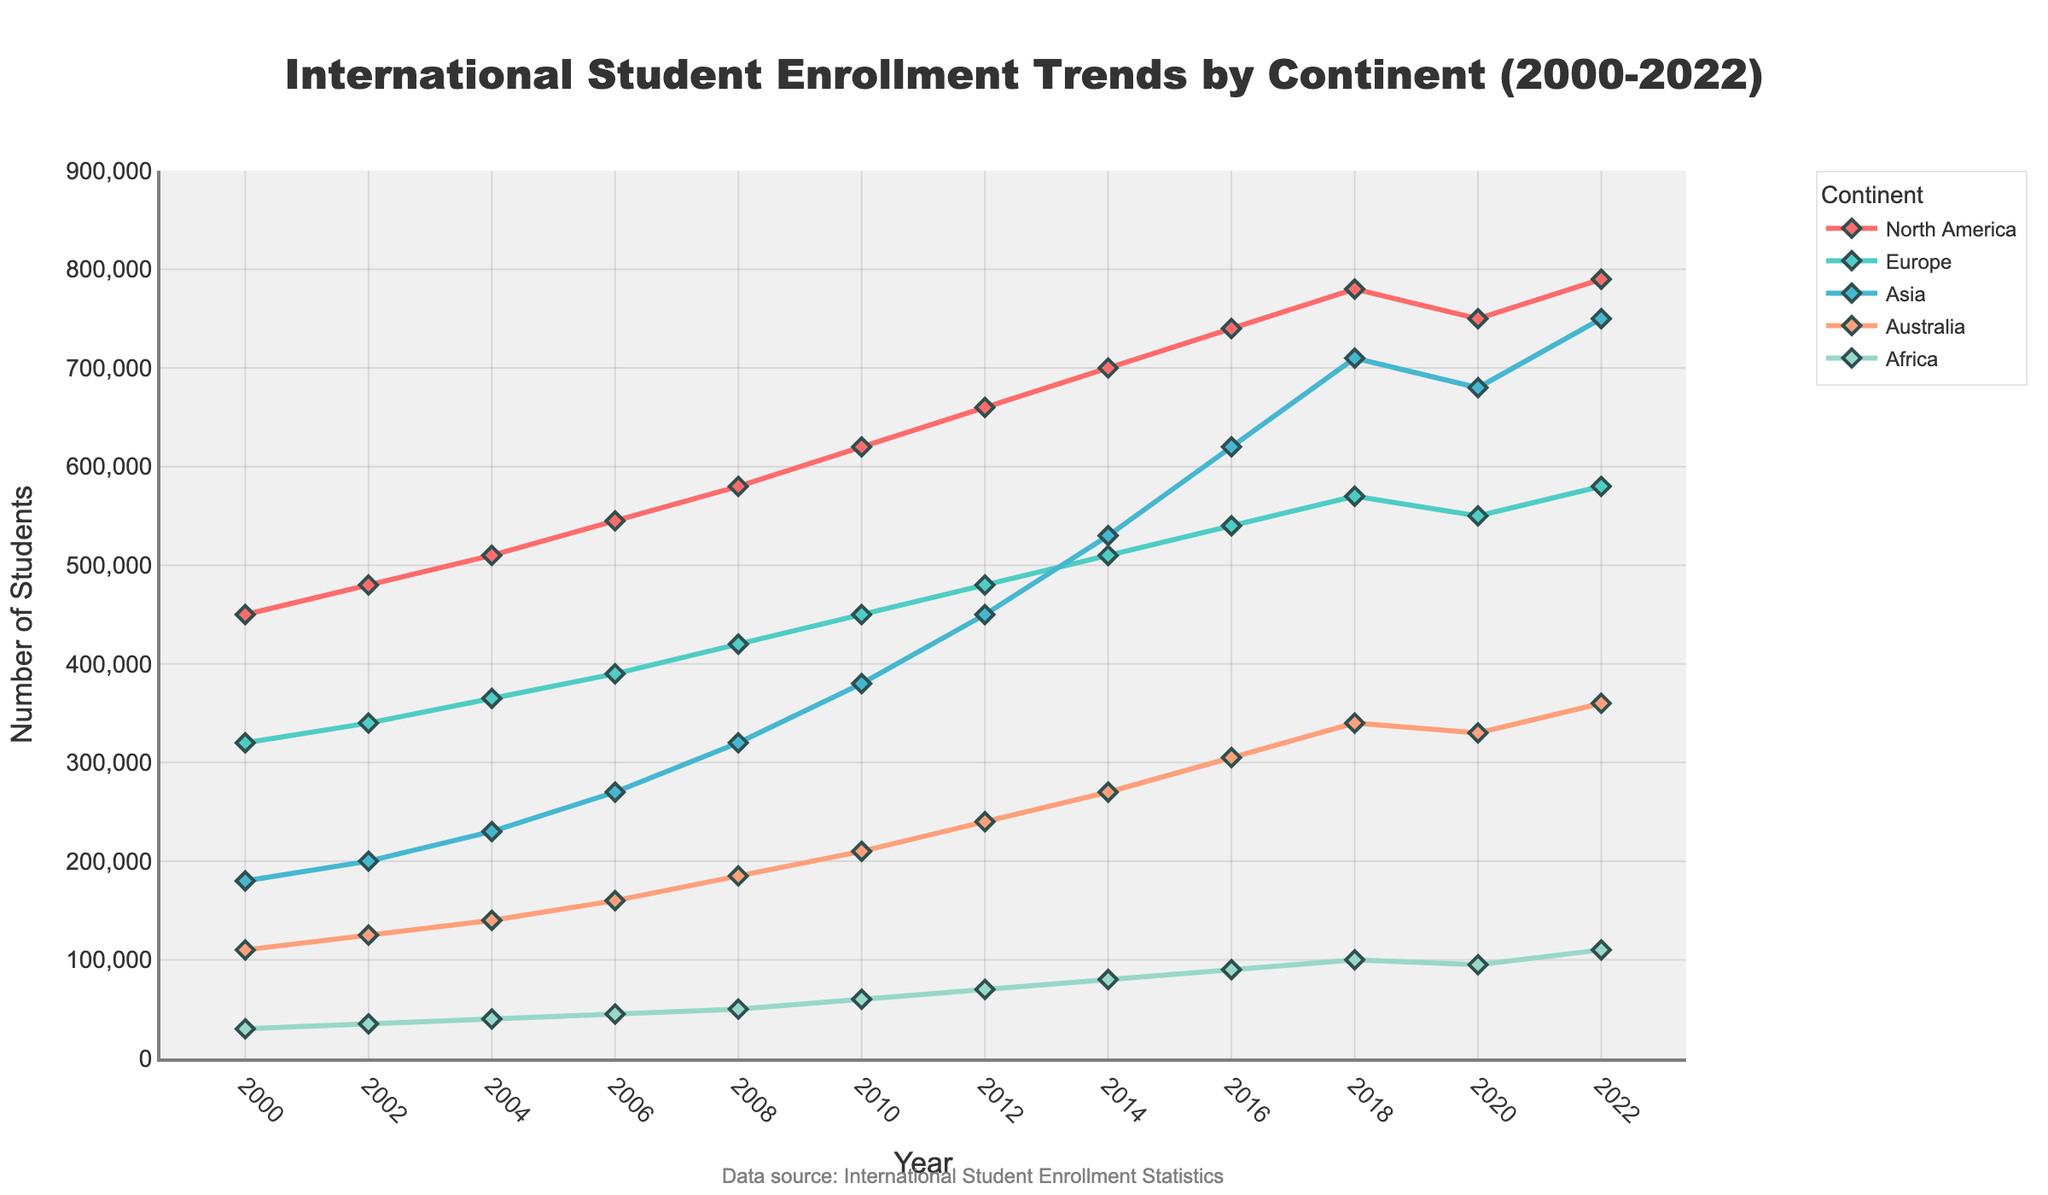What was the total number of international students enrolled in all continents in the year 2010? Sum the number of students for each continent in 2010: 620,000 (North America) + 450,000 (Europe) + 380,000 (Asia) + 210,000 (Australia) + 60,000 (Africa) = 1,720,000
Answer: 1,720,000 Which continent had the highest increase in international student enrollment from 2000 to 2022? Calculate the difference in student numbers for each continent between 2022 and 2000, then compare these values. North America: 790,000 - 450,000 = 340,000; Europe: 580,000 - 320,000 = 260,000; Asia: 750,000 - 180,000 = 570,000; Australia: 360,000 - 110,000 = 250,000; Africa: 110,000 - 30,000 = 80,000; Asia has the highest increase of 570,000
Answer: Asia Which year did Europe surpass 500,000 international students for the first time? Identify the year in which Europe's student enrollment first exceeds 500,000. It's in 2014, where Europe has an enrollment of 510,000 students
Answer: 2014 What is the difference in the number of international students in Asia between the years 2016 and 2020? Subtract the number of students in Asia in 2020 from the number in 2016: 680,000 (2020) - 620,000 (2016) = 60,000
Answer: 60,000 Which two continents show a trend of increasing international student enrollment at every measured point from 2000 to 2022? Identify the continents where the number of international students consistently increases in each subsequent year. Asia and Africa show continuous increases in student numbers over the whole period
Answer: Asia and Africa Between North America and Europe, which continent had more international students in 2022, and by how much? Compare the number of students in North America and Europe in 2022 and calculate the difference: North America (790,000) - Europe (580,000) = 210,000
Answer: North America, by 210,000 During which year did Australia have the smallest gap in international student enrollment compared to Africa? For each two-year point, calculate the absolute difference between Australia and Africa, identifying the smallest difference. In 2000: 110,000 - 30,000 = 80,000; 2002: 125,000 - 35,000 = 90,000; ..., 2022: 360,000 - 110,000 = 250,000. The smallest gap is 80,000, occurring in the year 2000
Answer: 2000 Which continent had the slowest growth in international student enrollment from 2000 to 2022? Calculate the growth for each continent and identify the smallest one: North America: 340,000; Europe: 260,000; Asia: 570,000; Australia: 250,000; Africa: 80,000. Africa has the slowest growth of 80,000
Answer: Africa From 2018 to 2020, which continent experienced a decline in international student enrollment, and by what percentage did their enrollment drop? Identify the continent and calculate the percentage drop: North America: (780,000 - 750,000)/780,000 * 100 = ~3.85%; Europe: (570,000 - 550,000)/570,000 * 100 = ~3.51%; Asia: (710,000 - 680,000)/710,000 * 100 = ~4.23%; Australia: (340,000 - 330,000)/340,000 * 100 = ~2.94%; Africa: (100,000 - 95,000)/100,000 * 100 = ~5%. All except Africa experienced declines, Asia had the highest percentage drop
Answer: Asia, 4.23% In which period did North America see the highest increase in international student enrollment? Calculate the increase for each two-year interval, identifying the largest increase. 2000-2002: 30,000; 2002-2004: 30,000; 2004-2006: 35,000; 2006-2008: 35,000; 2008-2010: 40,000; 2010-2012: 40,000; 2012-2014: 40,000; 2014-2016: 40,000; 2016-2018: 40,000; 2018-2020: -30,000; 2020-2022: 40,000. The highest increase of 40,000 occurred in multiple periods, including 2008-2010
Answer: 2008-2010 